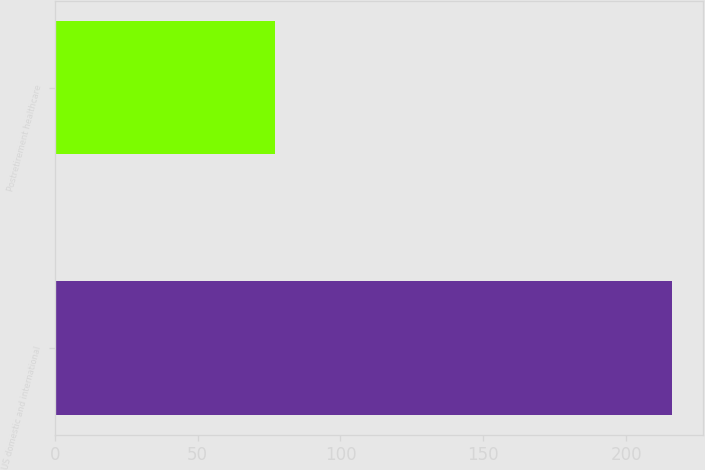Convert chart. <chart><loc_0><loc_0><loc_500><loc_500><bar_chart><fcel>US domestic and international<fcel>Postretirement healthcare<nl><fcel>216<fcel>77<nl></chart> 